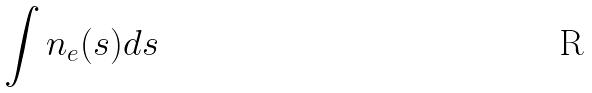Convert formula to latex. <formula><loc_0><loc_0><loc_500><loc_500>\int n _ { e } ( s ) d s</formula> 